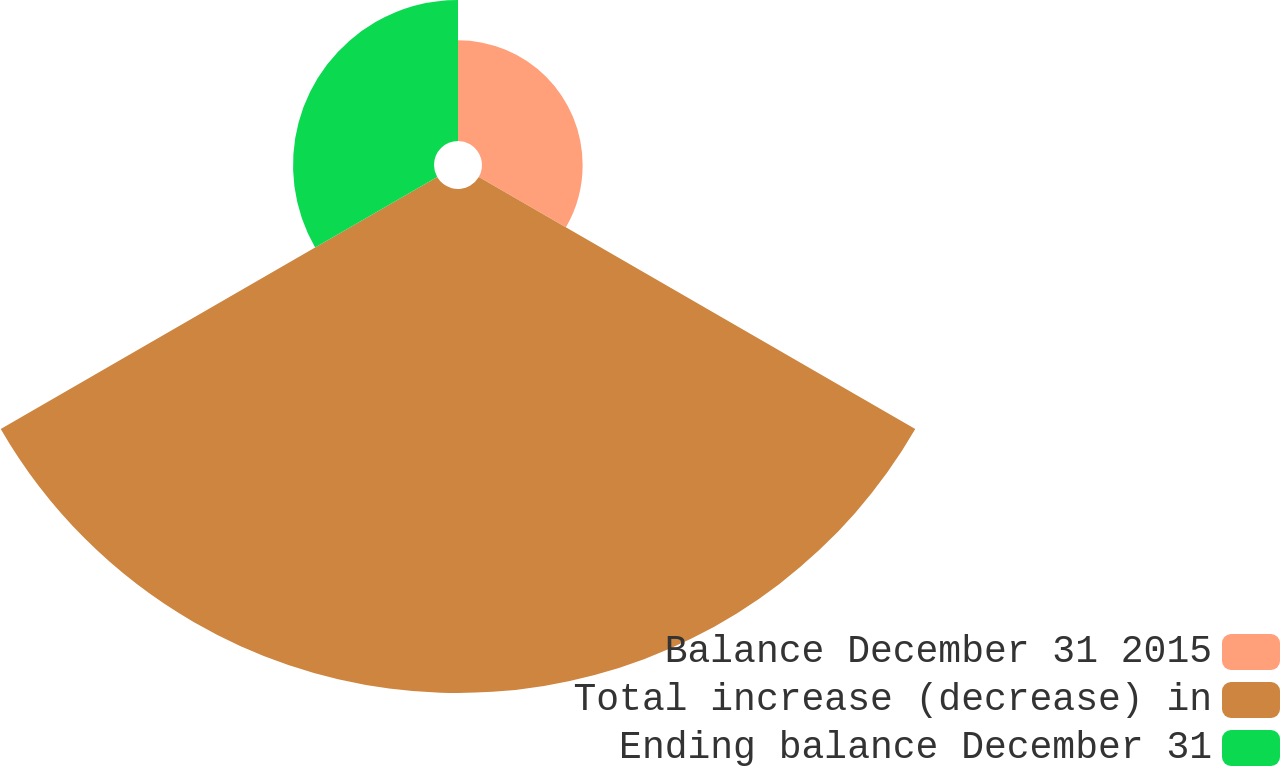Convert chart. <chart><loc_0><loc_0><loc_500><loc_500><pie_chart><fcel>Balance December 31 2015<fcel>Total increase (decrease) in<fcel>Ending balance December 31<nl><fcel>13.5%<fcel>67.6%<fcel>18.91%<nl></chart> 